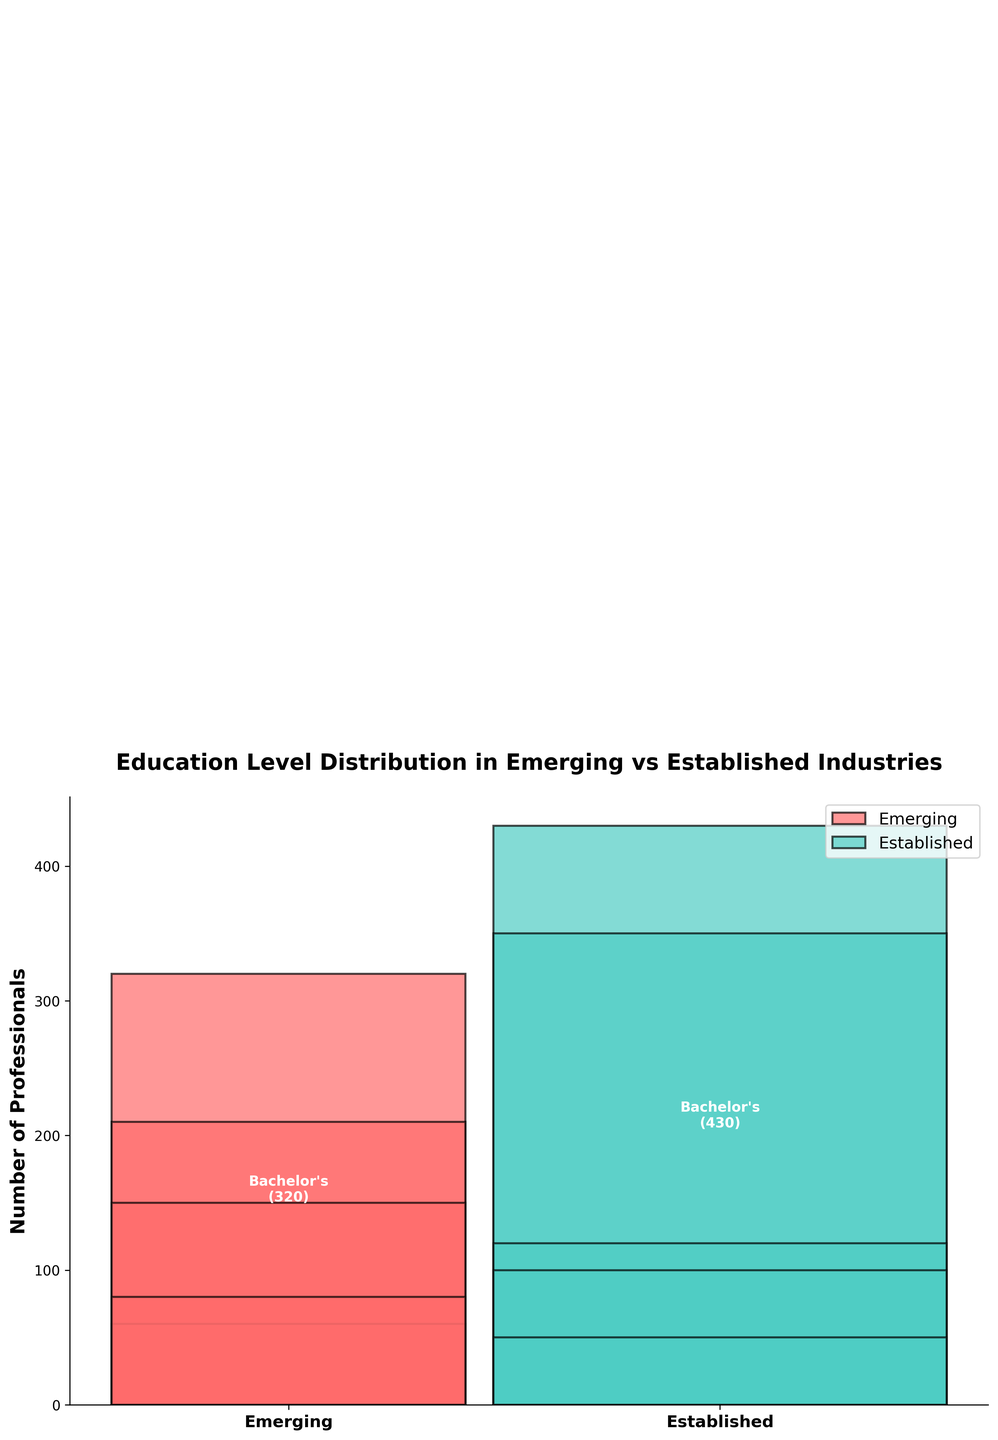What is the title of the plot? The title of the plot is usually found at the top of the graph, and it's the largest text there.
Answer: Education Level Distribution in Emerging vs Established Industries How are the industries differentiated in the plot? The industries are represented by different colors, with one color for Emerging and another for Established.
Answer: By color How many professionals with a Bachelor's degree are there in Emerging industries? Look at the segment marked "Bachelor's" for the Emerging industry; the text within this segment indicates the number of professionals.
Answer: 320 Which education level has the least number of professionals in the Established industry? Check all segments for the Established industry and find the one with the lowest number of professionals indicated within it.
Answer: High School Diploma What is the total number of professionals in the Emerging industry? Add up the number of professionals for each education level in the Emerging industry.
Answer: 820 What is the difference in the number of professionals with a Master's degree between Emerging and Established industries? Compare the number of professionals with a Master's degree in both industries and subtract the smaller number from the larger one.
Answer: 140 Which industry has a higher representation of PhD holders? Compare the number of PhD holders in the segments for both Emerging and Established industries.
Answer: Established What is the combined number of professionals with an Associate's degree in both industries? Add up the number of professionals with an Associate's degree from both the Emerging and Established industry segments.
Answer: 250 How does the width of the bars relate to the total number of professionals in each industry? The width is scaled proportionally, meaning an industry with a higher total number of professionals will have a wider bar.
Answer: Proportional to total number What is the most common education level in the Established industry? Identify the largest segment (in terms of height) in the bar for the Established industry.
Answer: Bachelor's 